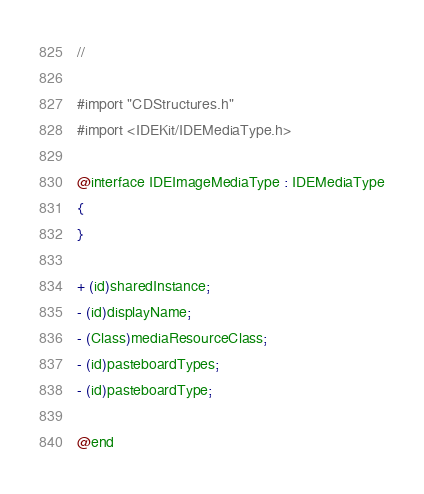<code> <loc_0><loc_0><loc_500><loc_500><_C_>//

#import "CDStructures.h"
#import <IDEKit/IDEMediaType.h>

@interface IDEImageMediaType : IDEMediaType
{
}

+ (id)sharedInstance;
- (id)displayName;
- (Class)mediaResourceClass;
- (id)pasteboardTypes;
- (id)pasteboardType;

@end

</code> 